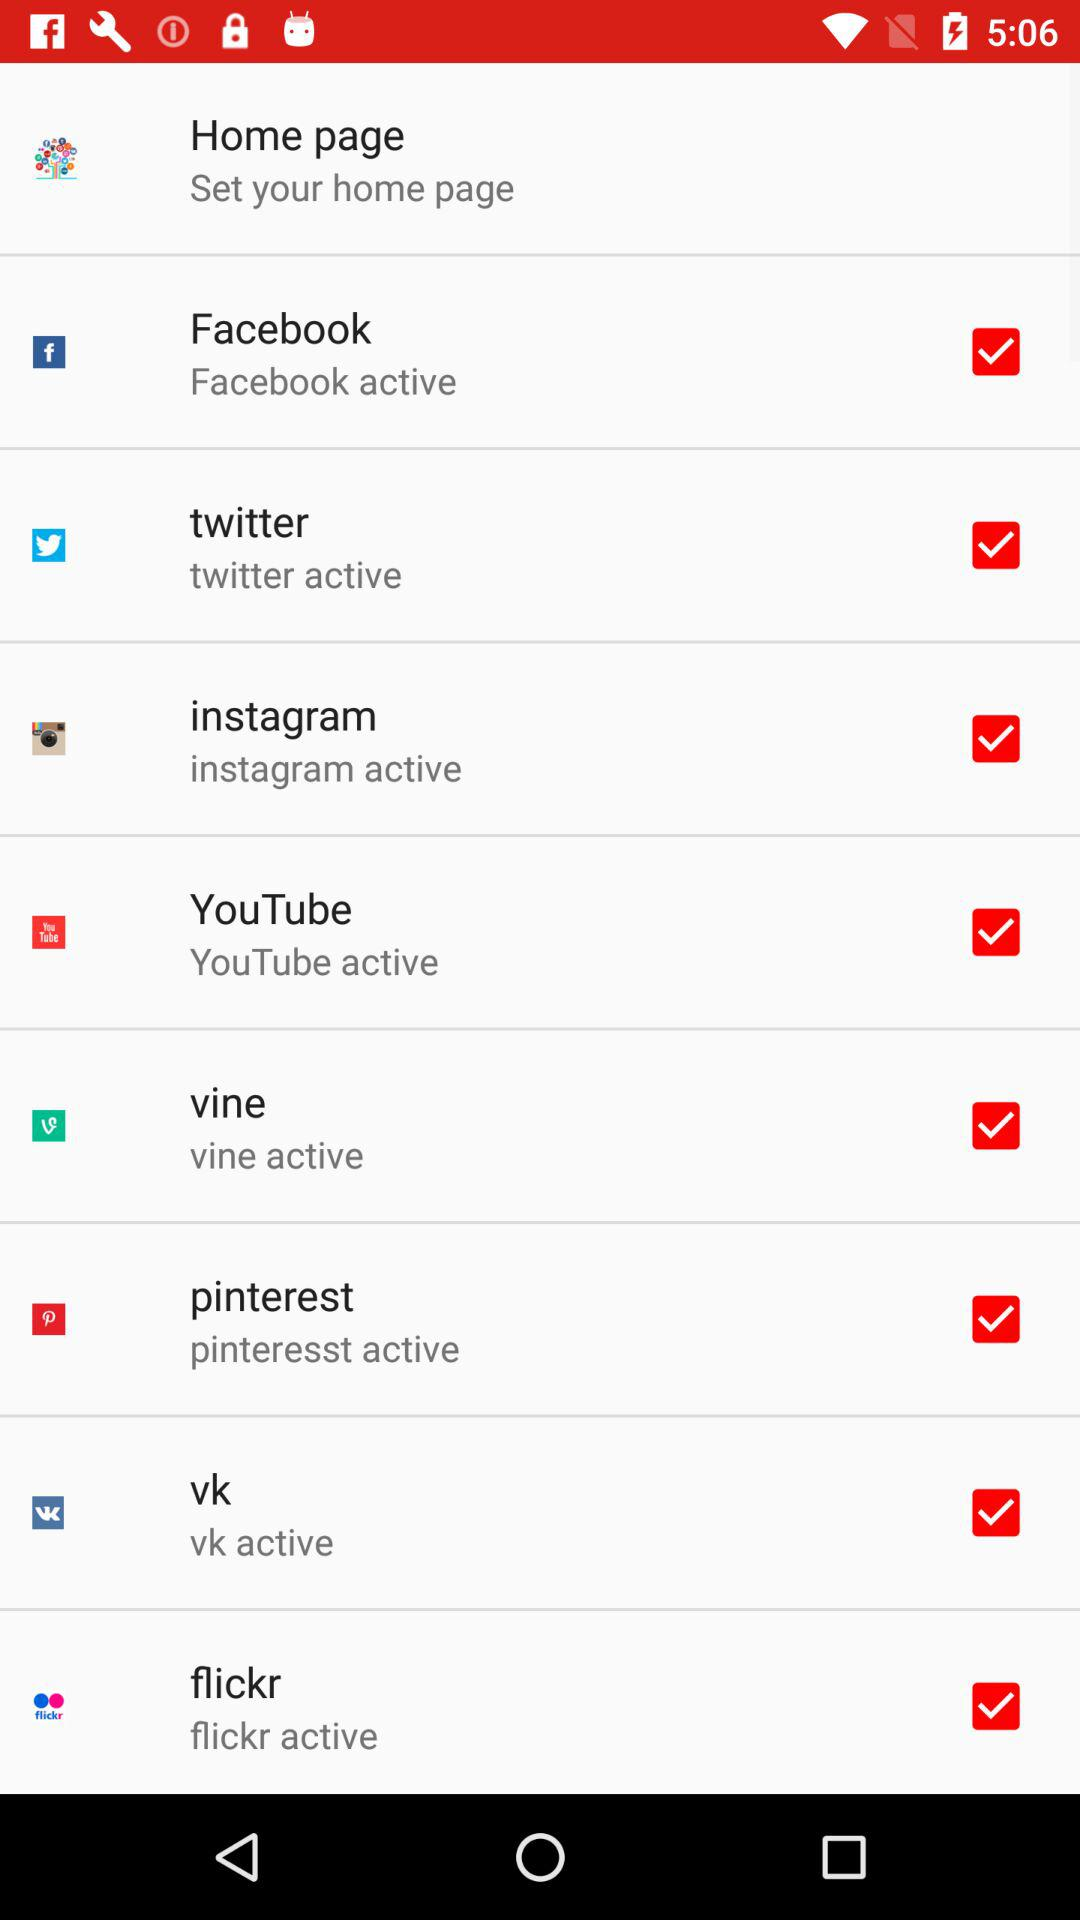What is the status of "Home page"?
When the provided information is insufficient, respond with <no answer>. <no answer> 